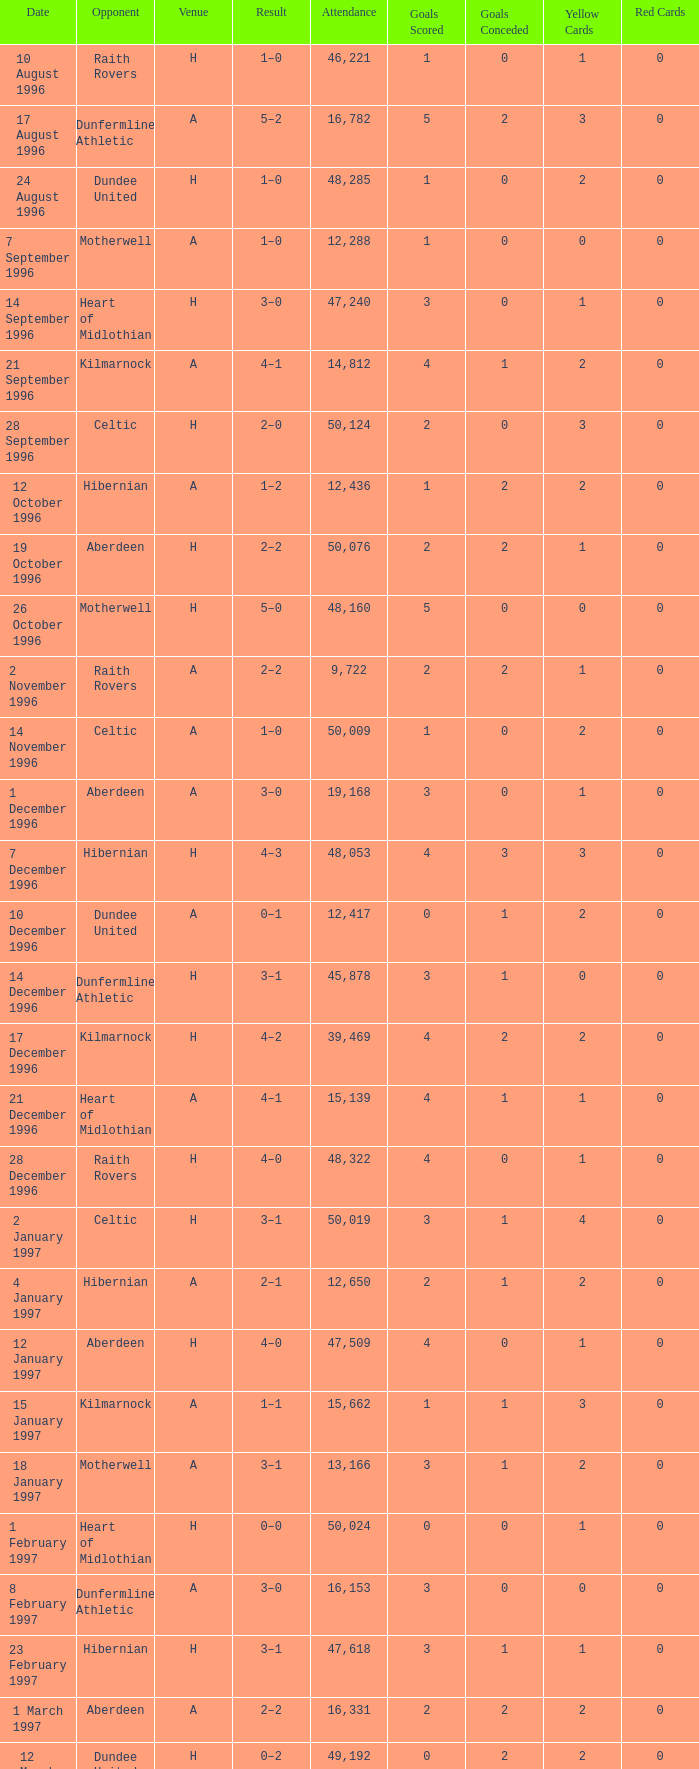When did venue A have an attendance larger than 48,053, and a result of 1–0? 14 November 1996, 16 March 1997. 